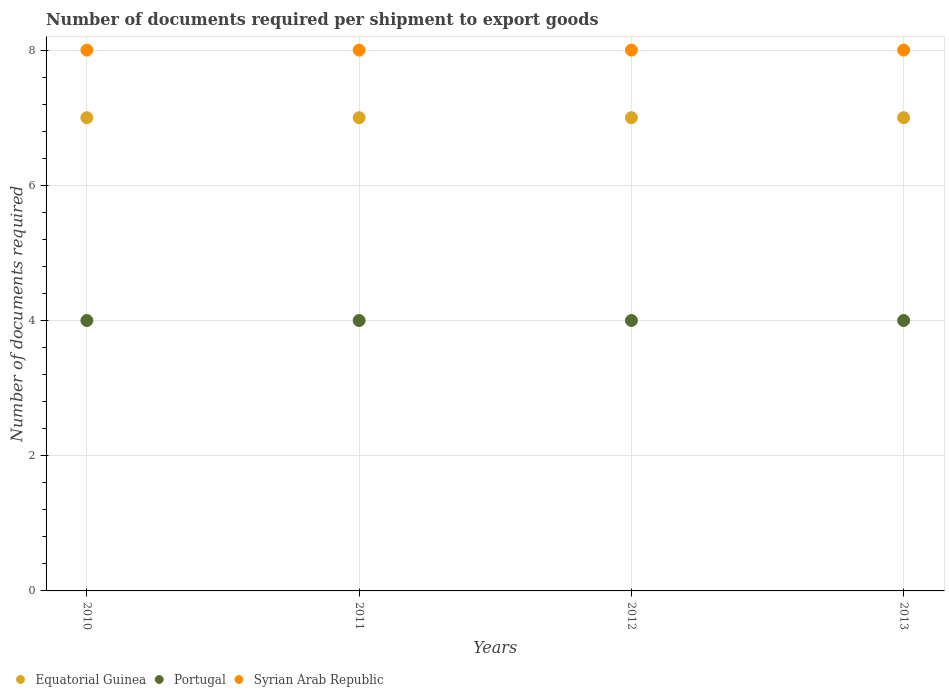Is the number of dotlines equal to the number of legend labels?
Your answer should be very brief. Yes. What is the number of documents required per shipment to export goods in Portugal in 2011?
Provide a succinct answer. 4. Across all years, what is the maximum number of documents required per shipment to export goods in Equatorial Guinea?
Your answer should be very brief. 7. Across all years, what is the minimum number of documents required per shipment to export goods in Portugal?
Provide a succinct answer. 4. In which year was the number of documents required per shipment to export goods in Syrian Arab Republic minimum?
Provide a short and direct response. 2010. What is the total number of documents required per shipment to export goods in Syrian Arab Republic in the graph?
Give a very brief answer. 32. What is the difference between the number of documents required per shipment to export goods in Equatorial Guinea in 2012 and the number of documents required per shipment to export goods in Portugal in 2010?
Make the answer very short. 3. What is the average number of documents required per shipment to export goods in Syrian Arab Republic per year?
Ensure brevity in your answer.  8. In the year 2013, what is the difference between the number of documents required per shipment to export goods in Portugal and number of documents required per shipment to export goods in Syrian Arab Republic?
Keep it short and to the point. -4. In how many years, is the number of documents required per shipment to export goods in Portugal greater than 0.8?
Offer a terse response. 4. What is the ratio of the number of documents required per shipment to export goods in Portugal in 2010 to that in 2013?
Give a very brief answer. 1. Is the number of documents required per shipment to export goods in Syrian Arab Republic in 2011 less than that in 2012?
Provide a short and direct response. No. Is the difference between the number of documents required per shipment to export goods in Portugal in 2011 and 2013 greater than the difference between the number of documents required per shipment to export goods in Syrian Arab Republic in 2011 and 2013?
Provide a short and direct response. No. What is the difference between the highest and the second highest number of documents required per shipment to export goods in Portugal?
Provide a succinct answer. 0. Is it the case that in every year, the sum of the number of documents required per shipment to export goods in Portugal and number of documents required per shipment to export goods in Syrian Arab Republic  is greater than the number of documents required per shipment to export goods in Equatorial Guinea?
Offer a very short reply. Yes. Does the number of documents required per shipment to export goods in Portugal monotonically increase over the years?
Your answer should be compact. No. How many dotlines are there?
Ensure brevity in your answer.  3. What is the difference between two consecutive major ticks on the Y-axis?
Provide a succinct answer. 2. Are the values on the major ticks of Y-axis written in scientific E-notation?
Offer a very short reply. No. Does the graph contain any zero values?
Your response must be concise. No. Does the graph contain grids?
Your answer should be very brief. Yes. How many legend labels are there?
Make the answer very short. 3. How are the legend labels stacked?
Your answer should be compact. Horizontal. What is the title of the graph?
Ensure brevity in your answer.  Number of documents required per shipment to export goods. Does "World" appear as one of the legend labels in the graph?
Provide a succinct answer. No. What is the label or title of the Y-axis?
Ensure brevity in your answer.  Number of documents required. What is the Number of documents required of Portugal in 2010?
Offer a very short reply. 4. What is the Number of documents required of Portugal in 2012?
Keep it short and to the point. 4. What is the Number of documents required of Syrian Arab Republic in 2012?
Your answer should be very brief. 8. What is the Number of documents required of Equatorial Guinea in 2013?
Ensure brevity in your answer.  7. What is the Number of documents required of Portugal in 2013?
Provide a short and direct response. 4. What is the Number of documents required in Syrian Arab Republic in 2013?
Provide a short and direct response. 8. Across all years, what is the minimum Number of documents required in Equatorial Guinea?
Offer a very short reply. 7. Across all years, what is the minimum Number of documents required in Syrian Arab Republic?
Offer a terse response. 8. What is the total Number of documents required in Equatorial Guinea in the graph?
Offer a very short reply. 28. What is the difference between the Number of documents required of Portugal in 2010 and that in 2011?
Keep it short and to the point. 0. What is the difference between the Number of documents required of Portugal in 2010 and that in 2013?
Your response must be concise. 0. What is the difference between the Number of documents required of Portugal in 2011 and that in 2012?
Give a very brief answer. 0. What is the difference between the Number of documents required in Syrian Arab Republic in 2011 and that in 2012?
Your answer should be compact. 0. What is the difference between the Number of documents required of Equatorial Guinea in 2011 and that in 2013?
Your answer should be compact. 0. What is the difference between the Number of documents required in Portugal in 2012 and that in 2013?
Offer a very short reply. 0. What is the difference between the Number of documents required in Equatorial Guinea in 2010 and the Number of documents required in Syrian Arab Republic in 2012?
Provide a short and direct response. -1. What is the difference between the Number of documents required of Portugal in 2010 and the Number of documents required of Syrian Arab Republic in 2012?
Provide a succinct answer. -4. What is the difference between the Number of documents required of Portugal in 2011 and the Number of documents required of Syrian Arab Republic in 2012?
Make the answer very short. -4. What is the difference between the Number of documents required of Equatorial Guinea in 2011 and the Number of documents required of Syrian Arab Republic in 2013?
Offer a terse response. -1. What is the difference between the Number of documents required of Equatorial Guinea in 2012 and the Number of documents required of Portugal in 2013?
Offer a terse response. 3. What is the difference between the Number of documents required in Equatorial Guinea in 2012 and the Number of documents required in Syrian Arab Republic in 2013?
Offer a terse response. -1. What is the difference between the Number of documents required of Portugal in 2012 and the Number of documents required of Syrian Arab Republic in 2013?
Offer a very short reply. -4. What is the average Number of documents required of Equatorial Guinea per year?
Give a very brief answer. 7. In the year 2010, what is the difference between the Number of documents required in Equatorial Guinea and Number of documents required in Portugal?
Your answer should be compact. 3. In the year 2012, what is the difference between the Number of documents required in Equatorial Guinea and Number of documents required in Portugal?
Offer a very short reply. 3. In the year 2012, what is the difference between the Number of documents required in Portugal and Number of documents required in Syrian Arab Republic?
Offer a very short reply. -4. What is the ratio of the Number of documents required of Portugal in 2010 to that in 2011?
Your answer should be compact. 1. What is the ratio of the Number of documents required in Syrian Arab Republic in 2010 to that in 2012?
Offer a very short reply. 1. What is the ratio of the Number of documents required in Portugal in 2010 to that in 2013?
Provide a succinct answer. 1. What is the ratio of the Number of documents required of Syrian Arab Republic in 2010 to that in 2013?
Your answer should be compact. 1. What is the ratio of the Number of documents required of Equatorial Guinea in 2011 to that in 2012?
Provide a succinct answer. 1. What is the ratio of the Number of documents required of Portugal in 2011 to that in 2012?
Your response must be concise. 1. What is the ratio of the Number of documents required of Syrian Arab Republic in 2011 to that in 2012?
Your answer should be very brief. 1. What is the ratio of the Number of documents required of Syrian Arab Republic in 2011 to that in 2013?
Ensure brevity in your answer.  1. What is the difference between the highest and the lowest Number of documents required of Portugal?
Keep it short and to the point. 0. What is the difference between the highest and the lowest Number of documents required of Syrian Arab Republic?
Your response must be concise. 0. 